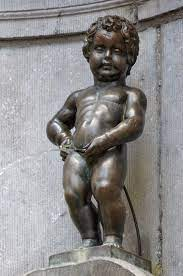Explain the visual content of the image in great detail.
 The image captures the renowned landmark, the Manneken Pis, situated in Brussels, Belgium. This bronze statue, perched on a stone pedestal, depicts a small boy in the act of urinating into a fountain. The backdrop is a gray stone wall, subtly adorned with a hint of greenery. The perspective of the image is from the front and slightly below the statue, providing a unique viewpoint of this iconic symbol of Brussels' rebellious spirit. 